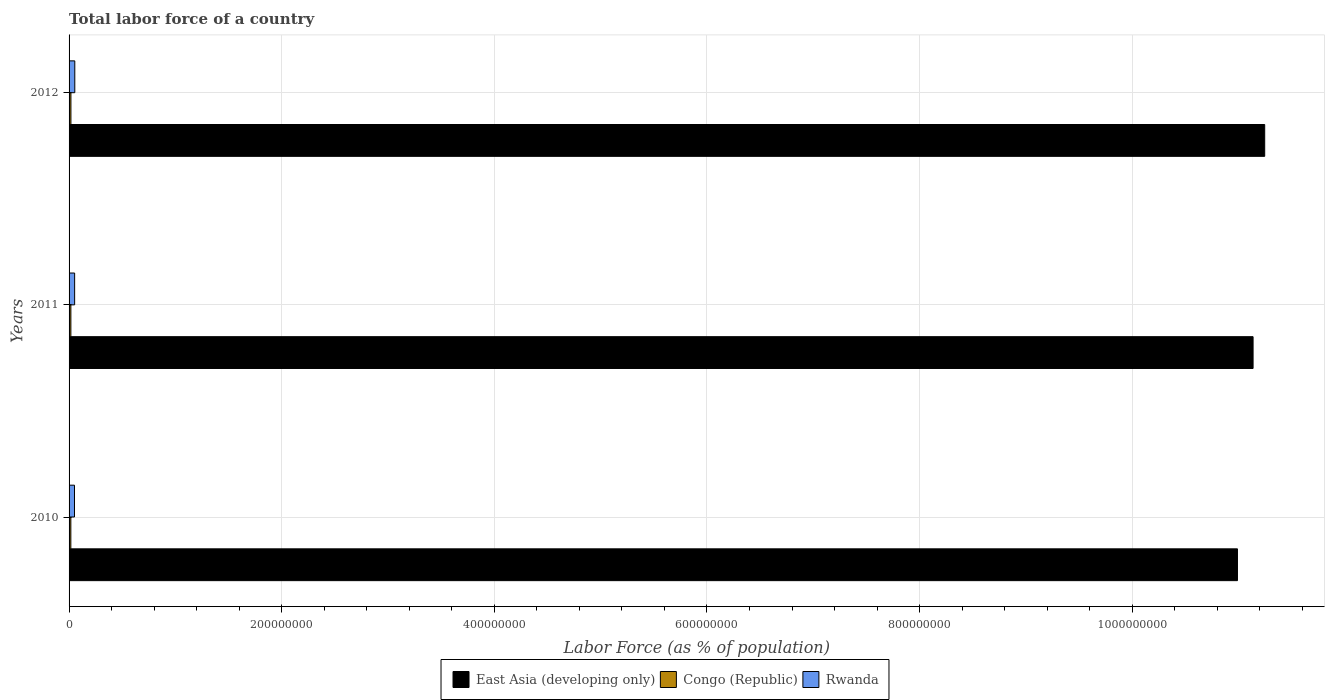How many groups of bars are there?
Make the answer very short. 3. Are the number of bars on each tick of the Y-axis equal?
Your answer should be compact. Yes. What is the label of the 1st group of bars from the top?
Your answer should be compact. 2012. In how many cases, is the number of bars for a given year not equal to the number of legend labels?
Keep it short and to the point. 0. What is the percentage of labor force in Rwanda in 2011?
Your answer should be very brief. 5.24e+06. Across all years, what is the maximum percentage of labor force in Congo (Republic)?
Offer a terse response. 1.74e+06. Across all years, what is the minimum percentage of labor force in East Asia (developing only)?
Your response must be concise. 1.10e+09. In which year was the percentage of labor force in East Asia (developing only) maximum?
Make the answer very short. 2012. In which year was the percentage of labor force in Congo (Republic) minimum?
Make the answer very short. 2010. What is the total percentage of labor force in East Asia (developing only) in the graph?
Provide a succinct answer. 3.34e+09. What is the difference between the percentage of labor force in Congo (Republic) in 2010 and that in 2012?
Your response must be concise. -8.23e+04. What is the difference between the percentage of labor force in East Asia (developing only) in 2010 and the percentage of labor force in Congo (Republic) in 2011?
Your answer should be compact. 1.10e+09. What is the average percentage of labor force in Congo (Republic) per year?
Your response must be concise. 1.70e+06. In the year 2011, what is the difference between the percentage of labor force in Rwanda and percentage of labor force in Congo (Republic)?
Offer a terse response. 3.54e+06. In how many years, is the percentage of labor force in Rwanda greater than 1120000000 %?
Your answer should be very brief. 0. What is the ratio of the percentage of labor force in East Asia (developing only) in 2010 to that in 2011?
Give a very brief answer. 0.99. What is the difference between the highest and the second highest percentage of labor force in Congo (Republic)?
Your answer should be very brief. 4.23e+04. What is the difference between the highest and the lowest percentage of labor force in Rwanda?
Provide a succinct answer. 2.73e+05. In how many years, is the percentage of labor force in Congo (Republic) greater than the average percentage of labor force in Congo (Republic) taken over all years?
Provide a short and direct response. 1. Is the sum of the percentage of labor force in Congo (Republic) in 2010 and 2012 greater than the maximum percentage of labor force in East Asia (developing only) across all years?
Give a very brief answer. No. What does the 1st bar from the top in 2012 represents?
Your answer should be very brief. Rwanda. What does the 1st bar from the bottom in 2010 represents?
Offer a terse response. East Asia (developing only). Are all the bars in the graph horizontal?
Ensure brevity in your answer.  Yes. What is the difference between two consecutive major ticks on the X-axis?
Give a very brief answer. 2.00e+08. Does the graph contain grids?
Give a very brief answer. Yes. Where does the legend appear in the graph?
Provide a short and direct response. Bottom center. How many legend labels are there?
Provide a short and direct response. 3. How are the legend labels stacked?
Give a very brief answer. Horizontal. What is the title of the graph?
Ensure brevity in your answer.  Total labor force of a country. What is the label or title of the X-axis?
Your response must be concise. Labor Force (as % of population). What is the Labor Force (as % of population) of East Asia (developing only) in 2010?
Your response must be concise. 1.10e+09. What is the Labor Force (as % of population) in Congo (Republic) in 2010?
Give a very brief answer. 1.66e+06. What is the Labor Force (as % of population) in Rwanda in 2010?
Make the answer very short. 5.11e+06. What is the Labor Force (as % of population) in East Asia (developing only) in 2011?
Your answer should be very brief. 1.11e+09. What is the Labor Force (as % of population) of Congo (Republic) in 2011?
Provide a succinct answer. 1.70e+06. What is the Labor Force (as % of population) of Rwanda in 2011?
Your answer should be very brief. 5.24e+06. What is the Labor Force (as % of population) of East Asia (developing only) in 2012?
Offer a terse response. 1.12e+09. What is the Labor Force (as % of population) in Congo (Republic) in 2012?
Provide a succinct answer. 1.74e+06. What is the Labor Force (as % of population) of Rwanda in 2012?
Offer a very short reply. 5.38e+06. Across all years, what is the maximum Labor Force (as % of population) of East Asia (developing only)?
Give a very brief answer. 1.12e+09. Across all years, what is the maximum Labor Force (as % of population) of Congo (Republic)?
Your response must be concise. 1.74e+06. Across all years, what is the maximum Labor Force (as % of population) in Rwanda?
Ensure brevity in your answer.  5.38e+06. Across all years, what is the minimum Labor Force (as % of population) in East Asia (developing only)?
Give a very brief answer. 1.10e+09. Across all years, what is the minimum Labor Force (as % of population) of Congo (Republic)?
Provide a short and direct response. 1.66e+06. Across all years, what is the minimum Labor Force (as % of population) of Rwanda?
Your answer should be very brief. 5.11e+06. What is the total Labor Force (as % of population) of East Asia (developing only) in the graph?
Provide a succinct answer. 3.34e+09. What is the total Labor Force (as % of population) of Congo (Republic) in the graph?
Ensure brevity in your answer.  5.11e+06. What is the total Labor Force (as % of population) of Rwanda in the graph?
Provide a succinct answer. 1.57e+07. What is the difference between the Labor Force (as % of population) in East Asia (developing only) in 2010 and that in 2011?
Make the answer very short. -1.47e+07. What is the difference between the Labor Force (as % of population) in Congo (Republic) in 2010 and that in 2011?
Give a very brief answer. -4.00e+04. What is the difference between the Labor Force (as % of population) in Rwanda in 2010 and that in 2011?
Ensure brevity in your answer.  -1.34e+05. What is the difference between the Labor Force (as % of population) of East Asia (developing only) in 2010 and that in 2012?
Offer a very short reply. -2.56e+07. What is the difference between the Labor Force (as % of population) in Congo (Republic) in 2010 and that in 2012?
Your answer should be very brief. -8.23e+04. What is the difference between the Labor Force (as % of population) of Rwanda in 2010 and that in 2012?
Your answer should be very brief. -2.73e+05. What is the difference between the Labor Force (as % of population) in East Asia (developing only) in 2011 and that in 2012?
Offer a very short reply. -1.09e+07. What is the difference between the Labor Force (as % of population) of Congo (Republic) in 2011 and that in 2012?
Your answer should be very brief. -4.23e+04. What is the difference between the Labor Force (as % of population) in Rwanda in 2011 and that in 2012?
Provide a short and direct response. -1.39e+05. What is the difference between the Labor Force (as % of population) of East Asia (developing only) in 2010 and the Labor Force (as % of population) of Congo (Republic) in 2011?
Your response must be concise. 1.10e+09. What is the difference between the Labor Force (as % of population) in East Asia (developing only) in 2010 and the Labor Force (as % of population) in Rwanda in 2011?
Offer a very short reply. 1.09e+09. What is the difference between the Labor Force (as % of population) of Congo (Republic) in 2010 and the Labor Force (as % of population) of Rwanda in 2011?
Offer a very short reply. -3.58e+06. What is the difference between the Labor Force (as % of population) of East Asia (developing only) in 2010 and the Labor Force (as % of population) of Congo (Republic) in 2012?
Ensure brevity in your answer.  1.10e+09. What is the difference between the Labor Force (as % of population) of East Asia (developing only) in 2010 and the Labor Force (as % of population) of Rwanda in 2012?
Your answer should be compact. 1.09e+09. What is the difference between the Labor Force (as % of population) in Congo (Republic) in 2010 and the Labor Force (as % of population) in Rwanda in 2012?
Make the answer very short. -3.72e+06. What is the difference between the Labor Force (as % of population) of East Asia (developing only) in 2011 and the Labor Force (as % of population) of Congo (Republic) in 2012?
Your answer should be compact. 1.11e+09. What is the difference between the Labor Force (as % of population) in East Asia (developing only) in 2011 and the Labor Force (as % of population) in Rwanda in 2012?
Offer a very short reply. 1.11e+09. What is the difference between the Labor Force (as % of population) in Congo (Republic) in 2011 and the Labor Force (as % of population) in Rwanda in 2012?
Provide a short and direct response. -3.68e+06. What is the average Labor Force (as % of population) of East Asia (developing only) per year?
Provide a short and direct response. 1.11e+09. What is the average Labor Force (as % of population) of Congo (Republic) per year?
Ensure brevity in your answer.  1.70e+06. What is the average Labor Force (as % of population) in Rwanda per year?
Provide a short and direct response. 5.24e+06. In the year 2010, what is the difference between the Labor Force (as % of population) in East Asia (developing only) and Labor Force (as % of population) in Congo (Republic)?
Ensure brevity in your answer.  1.10e+09. In the year 2010, what is the difference between the Labor Force (as % of population) of East Asia (developing only) and Labor Force (as % of population) of Rwanda?
Your response must be concise. 1.09e+09. In the year 2010, what is the difference between the Labor Force (as % of population) in Congo (Republic) and Labor Force (as % of population) in Rwanda?
Ensure brevity in your answer.  -3.44e+06. In the year 2011, what is the difference between the Labor Force (as % of population) of East Asia (developing only) and Labor Force (as % of population) of Congo (Republic)?
Your answer should be very brief. 1.11e+09. In the year 2011, what is the difference between the Labor Force (as % of population) in East Asia (developing only) and Labor Force (as % of population) in Rwanda?
Offer a very short reply. 1.11e+09. In the year 2011, what is the difference between the Labor Force (as % of population) in Congo (Republic) and Labor Force (as % of population) in Rwanda?
Make the answer very short. -3.54e+06. In the year 2012, what is the difference between the Labor Force (as % of population) in East Asia (developing only) and Labor Force (as % of population) in Congo (Republic)?
Provide a succinct answer. 1.12e+09. In the year 2012, what is the difference between the Labor Force (as % of population) in East Asia (developing only) and Labor Force (as % of population) in Rwanda?
Your answer should be compact. 1.12e+09. In the year 2012, what is the difference between the Labor Force (as % of population) in Congo (Republic) and Labor Force (as % of population) in Rwanda?
Provide a short and direct response. -3.63e+06. What is the ratio of the Labor Force (as % of population) of East Asia (developing only) in 2010 to that in 2011?
Keep it short and to the point. 0.99. What is the ratio of the Labor Force (as % of population) in Congo (Republic) in 2010 to that in 2011?
Make the answer very short. 0.98. What is the ratio of the Labor Force (as % of population) of Rwanda in 2010 to that in 2011?
Keep it short and to the point. 0.97. What is the ratio of the Labor Force (as % of population) in East Asia (developing only) in 2010 to that in 2012?
Provide a succinct answer. 0.98. What is the ratio of the Labor Force (as % of population) in Congo (Republic) in 2010 to that in 2012?
Provide a short and direct response. 0.95. What is the ratio of the Labor Force (as % of population) in Rwanda in 2010 to that in 2012?
Give a very brief answer. 0.95. What is the ratio of the Labor Force (as % of population) of East Asia (developing only) in 2011 to that in 2012?
Your answer should be compact. 0.99. What is the ratio of the Labor Force (as % of population) in Congo (Republic) in 2011 to that in 2012?
Ensure brevity in your answer.  0.98. What is the ratio of the Labor Force (as % of population) in Rwanda in 2011 to that in 2012?
Your answer should be very brief. 0.97. What is the difference between the highest and the second highest Labor Force (as % of population) of East Asia (developing only)?
Provide a succinct answer. 1.09e+07. What is the difference between the highest and the second highest Labor Force (as % of population) of Congo (Republic)?
Give a very brief answer. 4.23e+04. What is the difference between the highest and the second highest Labor Force (as % of population) in Rwanda?
Keep it short and to the point. 1.39e+05. What is the difference between the highest and the lowest Labor Force (as % of population) of East Asia (developing only)?
Your answer should be very brief. 2.56e+07. What is the difference between the highest and the lowest Labor Force (as % of population) of Congo (Republic)?
Make the answer very short. 8.23e+04. What is the difference between the highest and the lowest Labor Force (as % of population) of Rwanda?
Your answer should be very brief. 2.73e+05. 